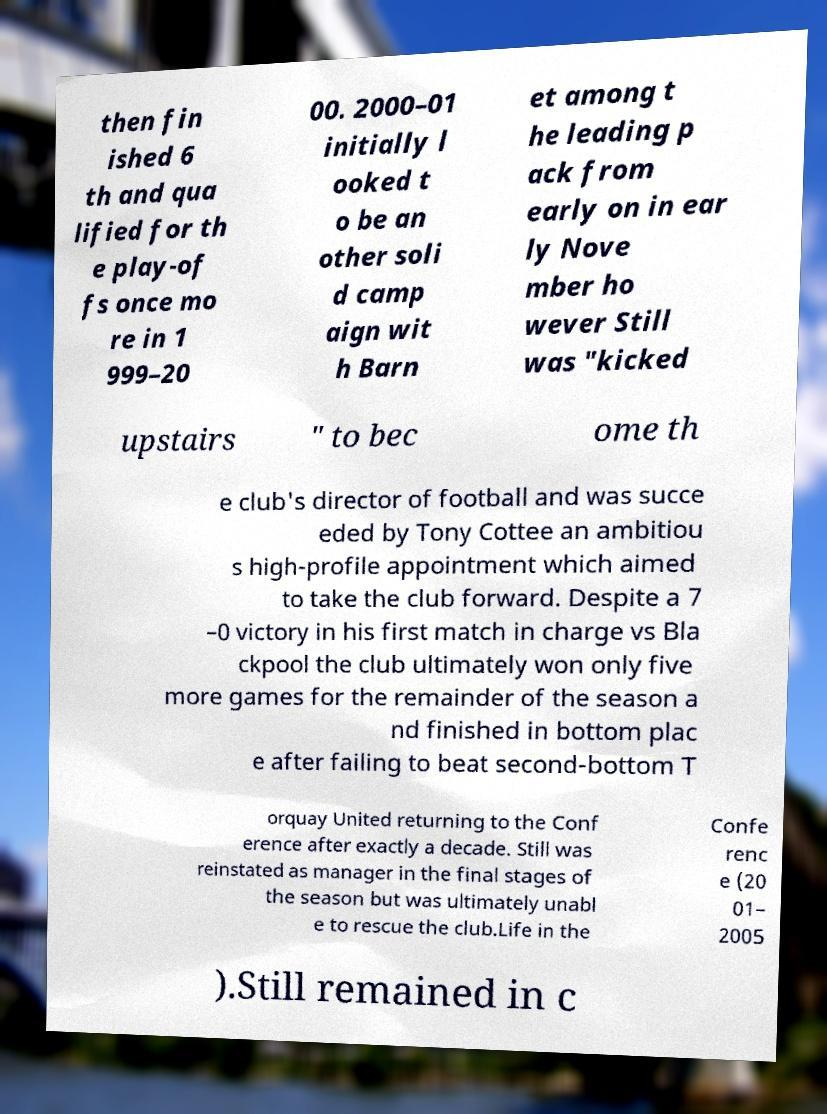For documentation purposes, I need the text within this image transcribed. Could you provide that? then fin ished 6 th and qua lified for th e play-of fs once mo re in 1 999–20 00. 2000–01 initially l ooked t o be an other soli d camp aign wit h Barn et among t he leading p ack from early on in ear ly Nove mber ho wever Still was "kicked upstairs " to bec ome th e club's director of football and was succe eded by Tony Cottee an ambitiou s high-profile appointment which aimed to take the club forward. Despite a 7 –0 victory in his first match in charge vs Bla ckpool the club ultimately won only five more games for the remainder of the season a nd finished in bottom plac e after failing to beat second-bottom T orquay United returning to the Conf erence after exactly a decade. Still was reinstated as manager in the final stages of the season but was ultimately unabl e to rescue the club.Life in the Confe renc e (20 01– 2005 ).Still remained in c 